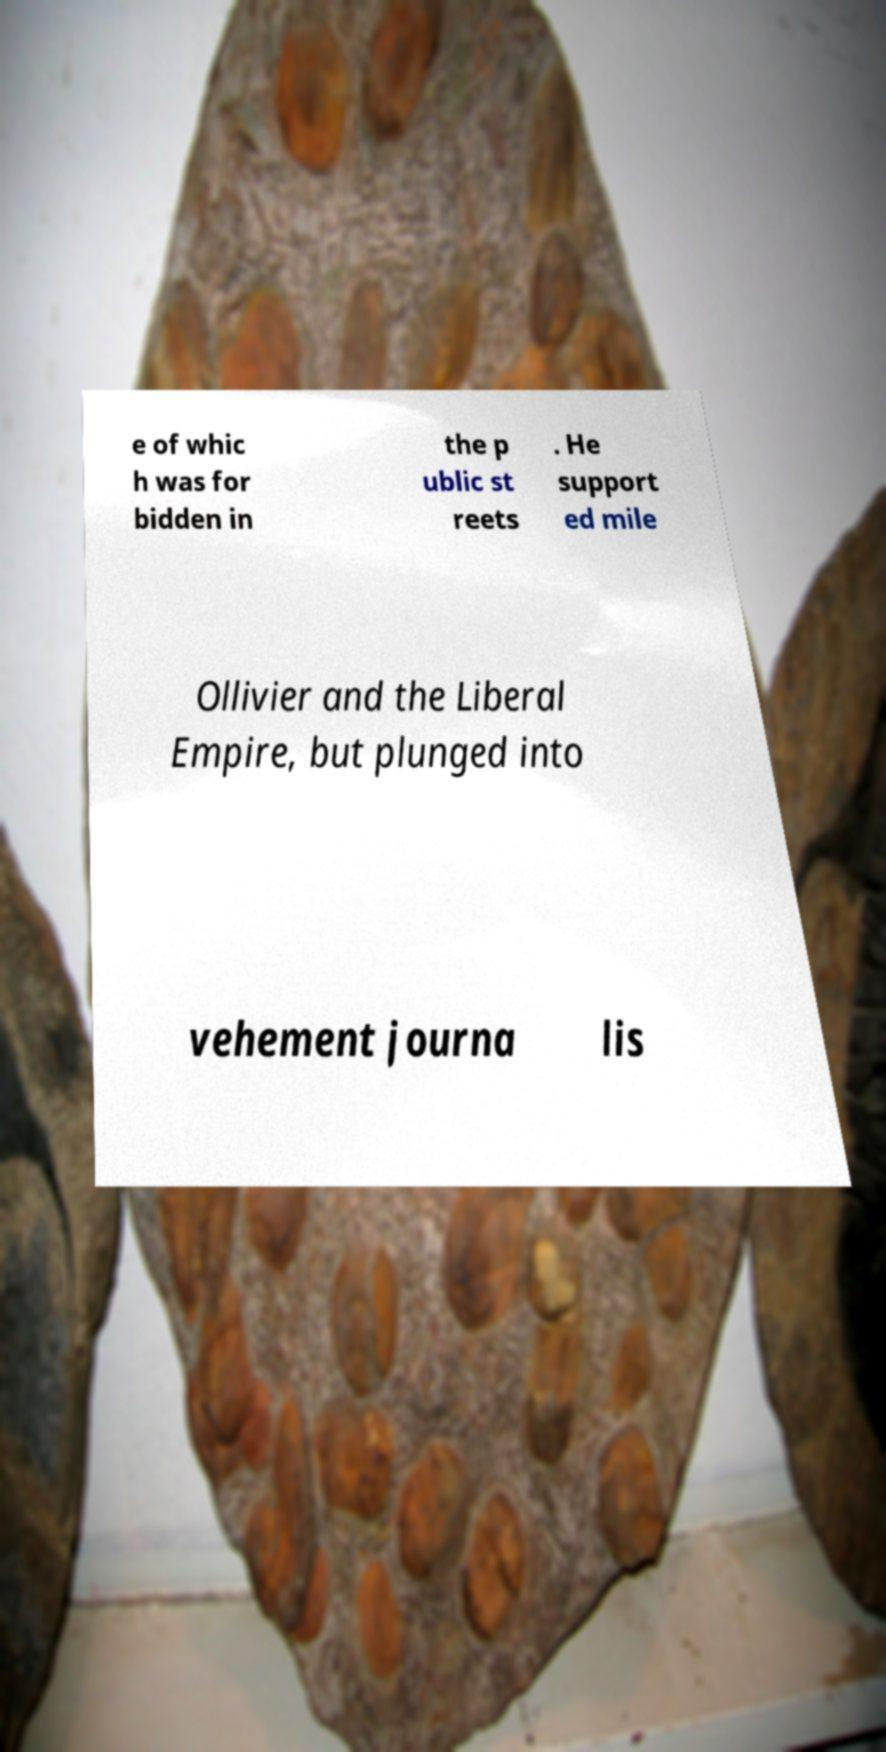I need the written content from this picture converted into text. Can you do that? e of whic h was for bidden in the p ublic st reets . He support ed mile Ollivier and the Liberal Empire, but plunged into vehement journa lis 